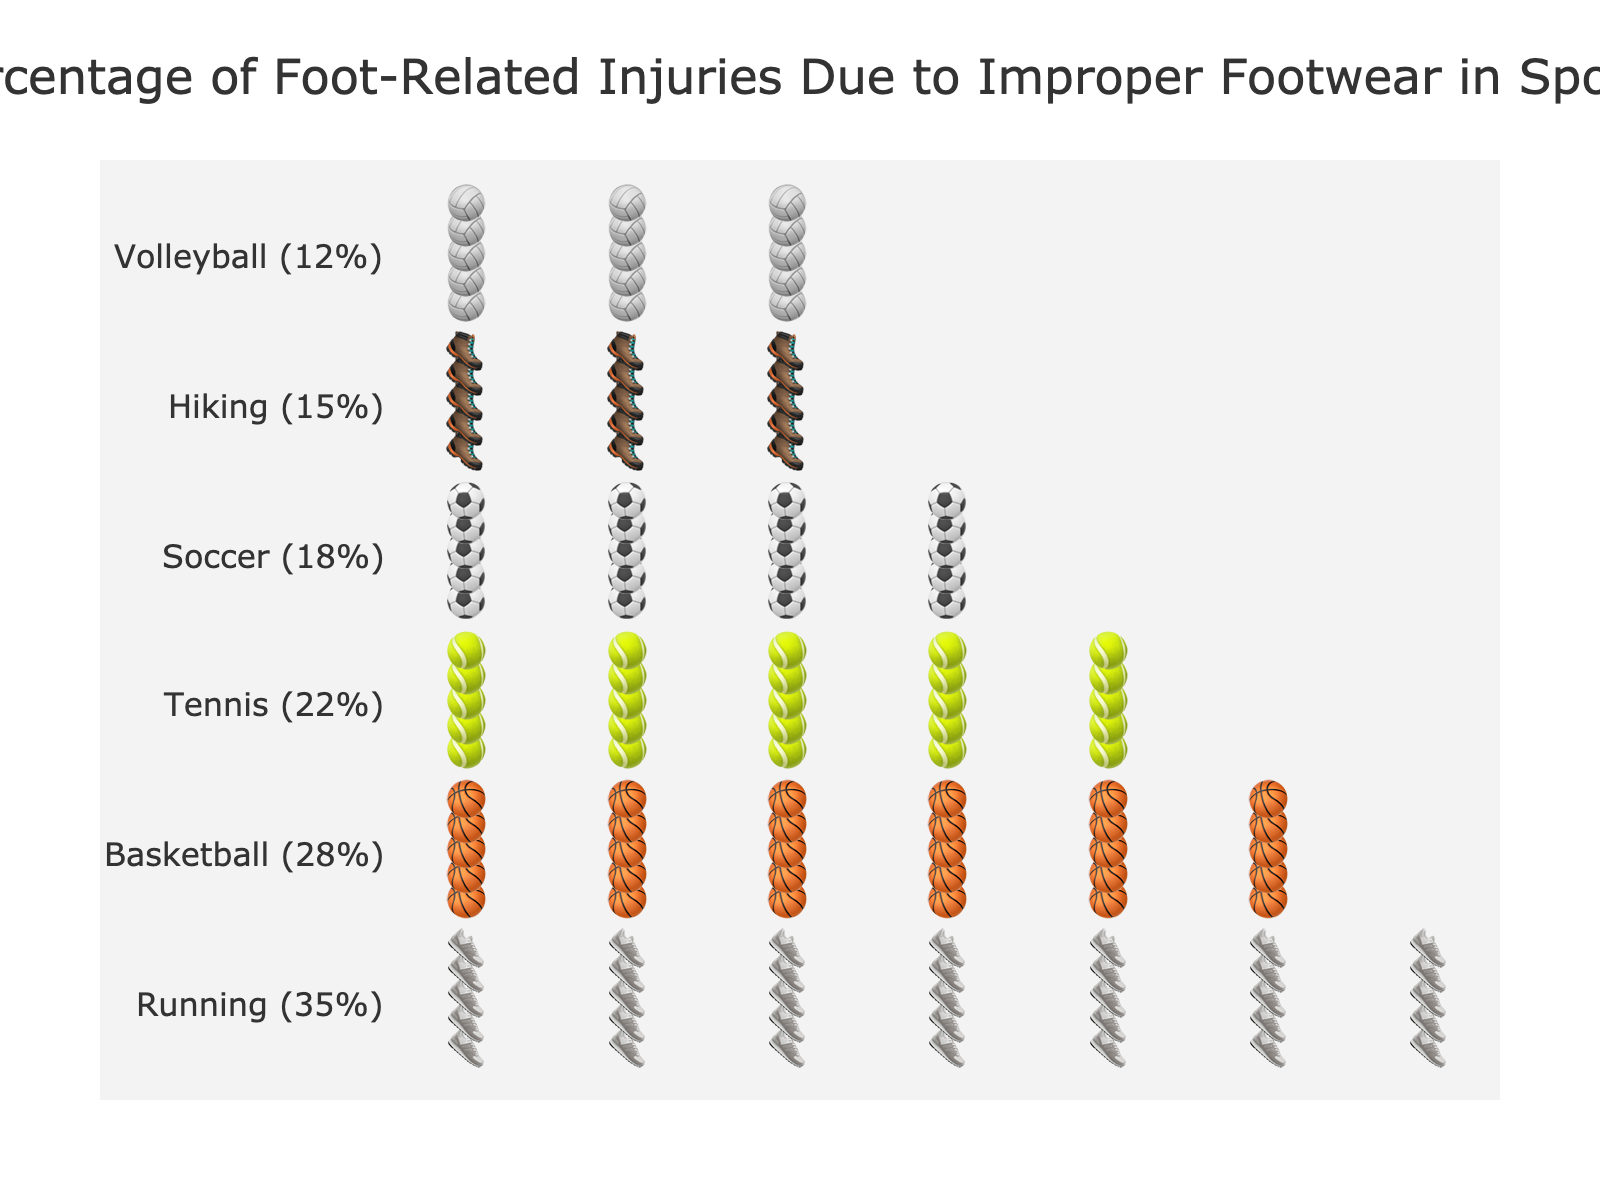What's the sport with the highest percentage of foot-related injuries due to improper footwear? The figure shows that running has the highest number of shoe icons, which correspond to foot-related injuries. The injury rate is displayed next to each sport's label. Running leads with 35%.
Answer: Running What's the total percentage of foot-related injuries for Basketball and Tennis combined? The injury percentages for Basketball and Tennis are 28% and 22%, respectively. Adding these gives 28 + 22 = 50%.
Answer: 50% Which sport has fewer foot-related injuries, Soccer or Hiking? The figure shows that Soccer has 18% and Hiking has 15%. Since 15 is less than 18, Hiking has the fewer foot-related injuries.
Answer: Hiking How many more injuries per 100 are attributed to improper footwear in Running compared to Volleyball? Running has 35 injuries per 100, and Volleyball has 12 injuries per 100. The difference is 35 - 12 = 23.
Answer: 23 What is the average percentage of foot-related injuries for Tennis, Soccer, and Volleyball? The injury percentages are: Tennis (22%), Soccer (18%), Volleyball (12%). Adding these together gives 22 + 18 + 12 = 52. Dividing by the number of sports (3) gives 52 / 3 ≈ 17.33%.
Answer: 17.33% What's the sport with the lowest percentage of foot-related injuries due to improper footwear? The figure shows the lowest number of shoe icons for Volleyball, indicating the lowest injury percentage, which is 12%.
Answer: Volleyball Which two sports have the closest percentages of foot-related injuries? From the percentages shown, Soccer (18%) and Hiking (15%) have close values, with a difference of only 3%.
Answer: Soccer and Hiking Is percentage of foot-related injuries due to improper footwear in Soccer higher or lower than Basketball? The figure shows that Soccer has 18% and Basketball has 28%. Since 18% is lower than 28%, Soccer has a lower percentage of injuries.
Answer: Lower 